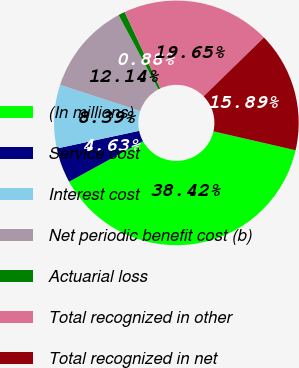Convert chart to OTSL. <chart><loc_0><loc_0><loc_500><loc_500><pie_chart><fcel>(In millions)<fcel>Service cost<fcel>Interest cost<fcel>Net periodic benefit cost (b)<fcel>Actuarial loss<fcel>Total recognized in other<fcel>Total recognized in net<nl><fcel>38.42%<fcel>4.63%<fcel>8.39%<fcel>12.14%<fcel>0.88%<fcel>19.65%<fcel>15.89%<nl></chart> 